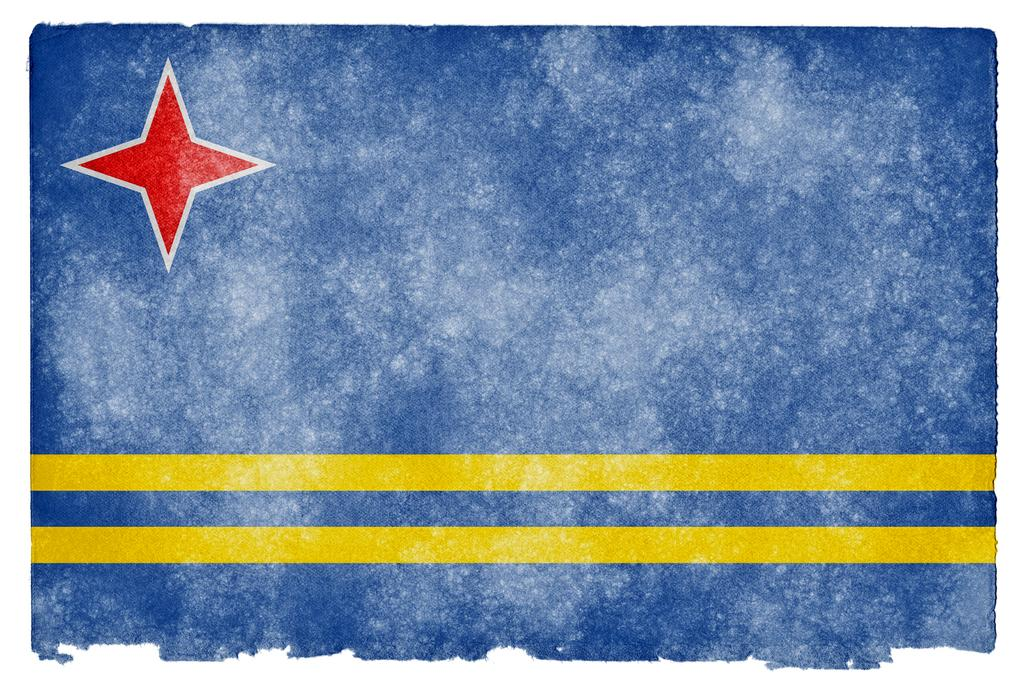What are the two prominent lines in the image? There are two yellow parallel lines in the image. What shape and color is the object in the image? There is a red colored star in the image. What color is the background of the image? The background of the image is blue. Can you tell me how the stream flows in the image? There is no stream present in the image; it features two yellow parallel lines and a red colored star against a blue background. What type of approval is required for the red star in the image? There is no indication in the image that any approval is required for the red star. 